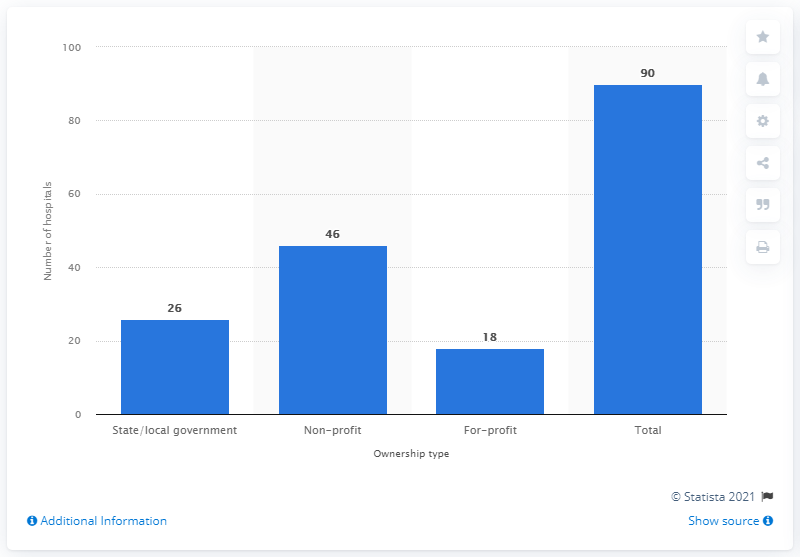Give some essential details in this illustration. In 2019, there were 26 hospitals in Colorado that were owned by the state or local government. 